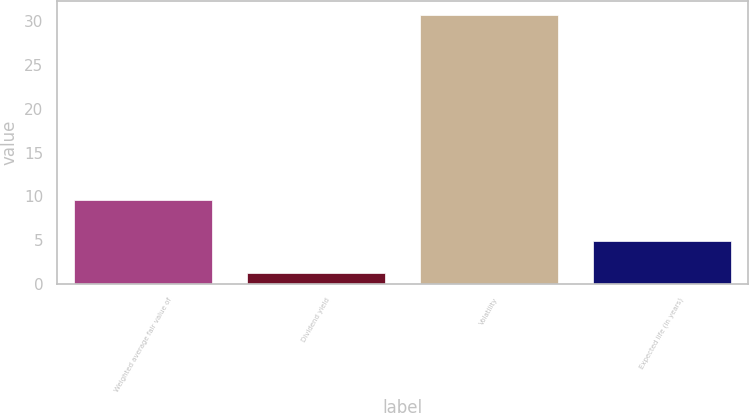Convert chart. <chart><loc_0><loc_0><loc_500><loc_500><bar_chart><fcel>Weighted average fair value of<fcel>Dividend yield<fcel>Volatility<fcel>Expected life (in years)<nl><fcel>9.61<fcel>1.21<fcel>30.76<fcel>4.93<nl></chart> 